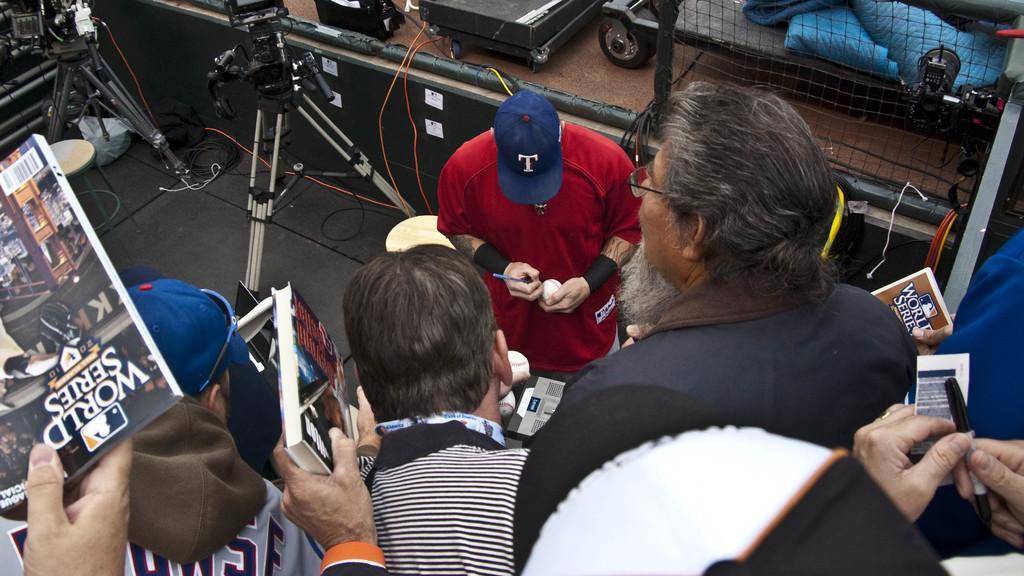Please provide a concise description of this image. In this image I can see group of people standing, the person in front wearing red color shirt holding a pen and a ball, in front I can see few cameras and I can see a cloth in blue color. 